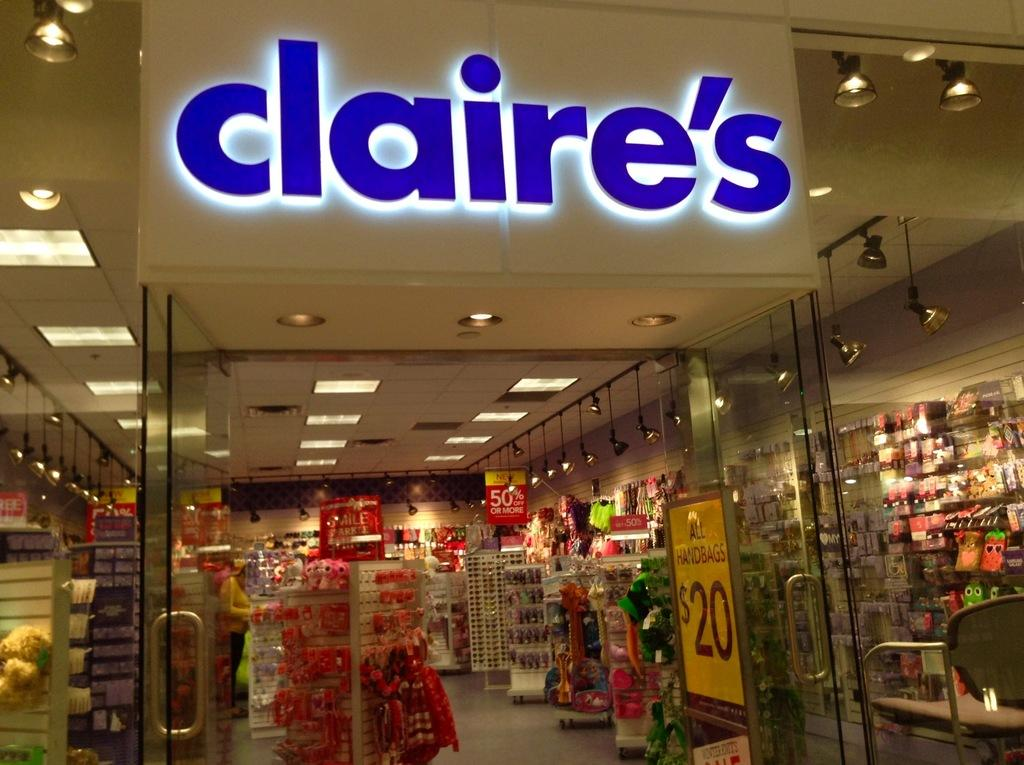<image>
Describe the image concisely. Claire's store doorway with shelves and other displays inside. 